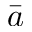Convert formula to latex. <formula><loc_0><loc_0><loc_500><loc_500>\bar { a }</formula> 